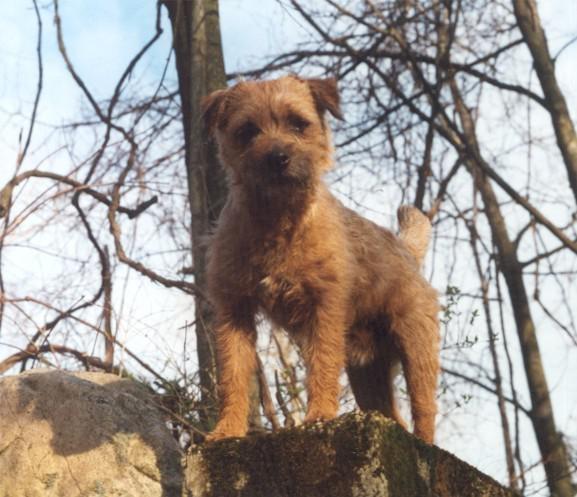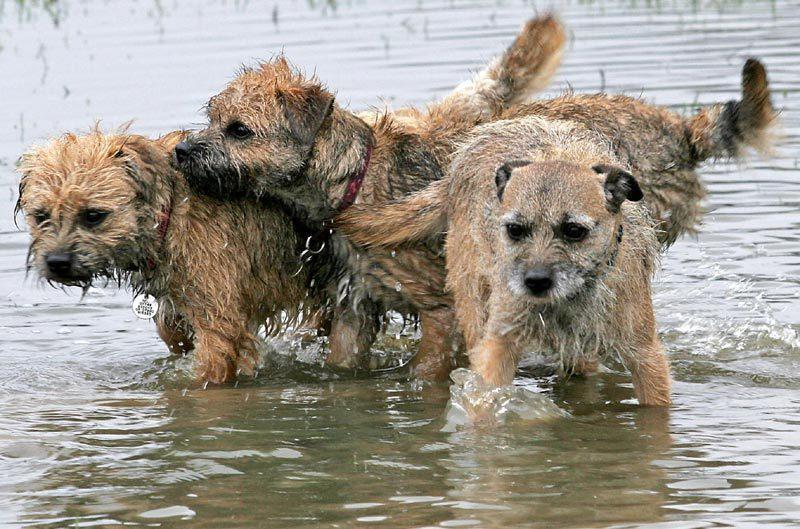The first image is the image on the left, the second image is the image on the right. Examine the images to the left and right. Is the description "At least one image shows a small dog standing on green grass." accurate? Answer yes or no. No. The first image is the image on the left, the second image is the image on the right. Examine the images to the left and right. Is the description "At least one dog is standing on grass." accurate? Answer yes or no. No. The first image is the image on the left, the second image is the image on the right. Assess this claim about the two images: "A dog is standing in the grass with the paw on the left raised.". Correct or not? Answer yes or no. No. 